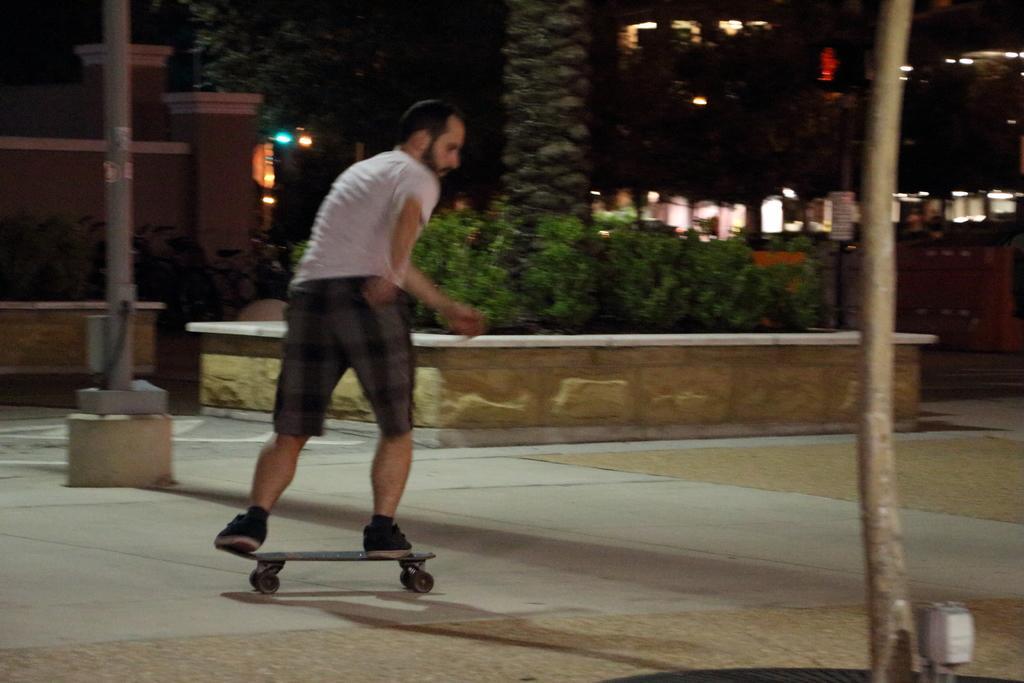Can you describe this image briefly? In this image I see a man who is wearing a t-shirt and shorts and he is on this skateboard and I see the path and I see a pole over here and I see few plants over here and I see that it is a bit dark in the background and I see the lights. 